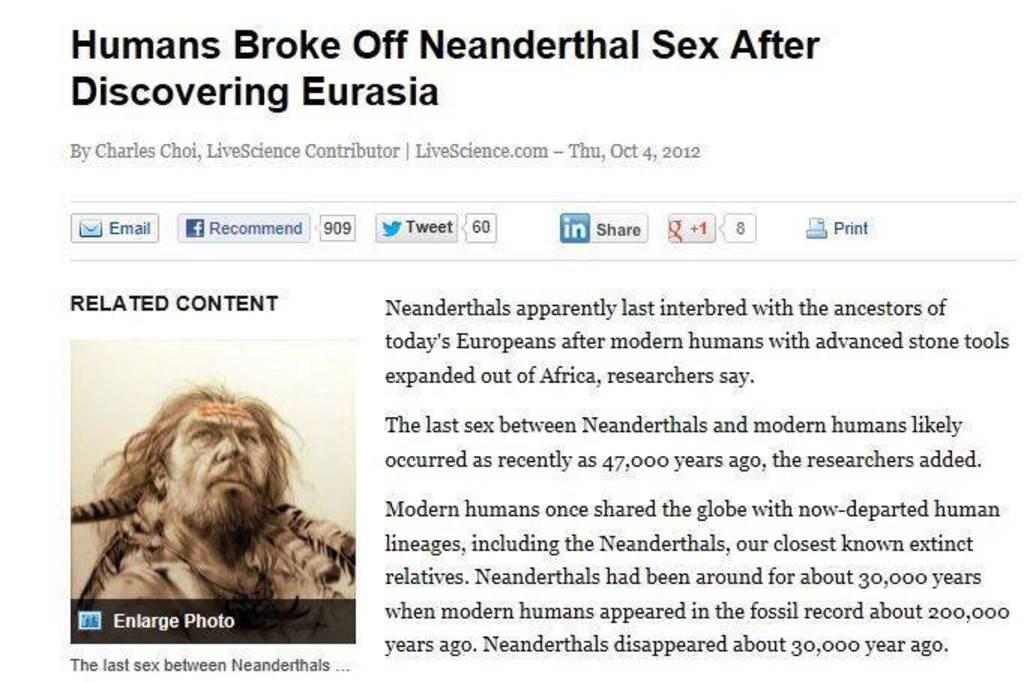Describe this image in one or two sentences. This is a post. There is a side heading and texts written on it and on the left we can see a picture of a person. 